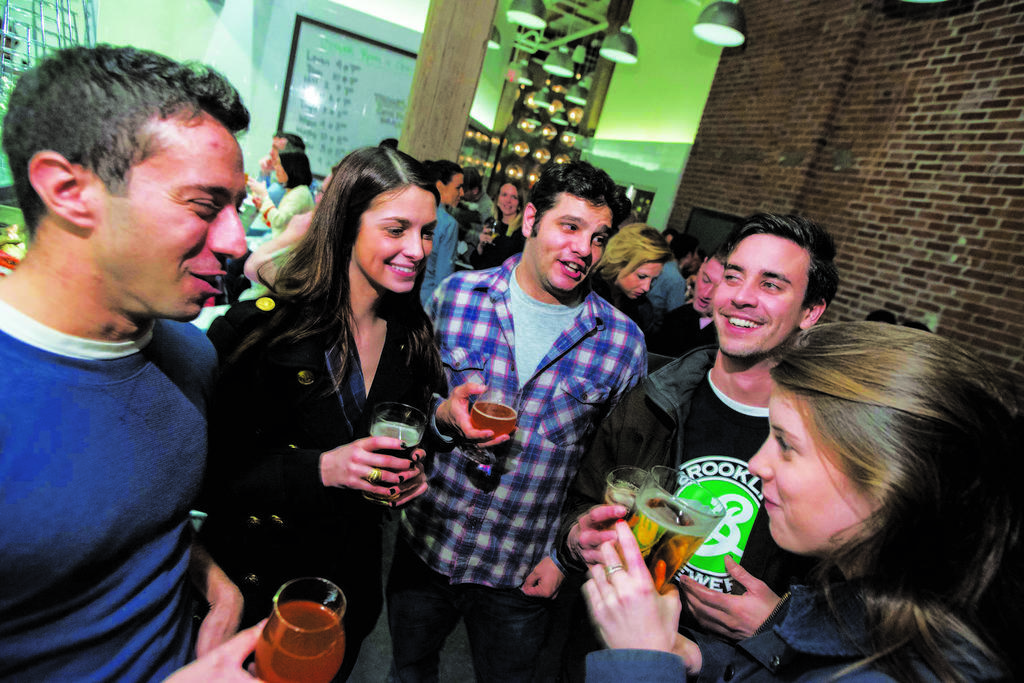Describe this image in one or two sentences. in the image we can see few persons were standing and holding glass and they were smiling. In the background there is a wall,light,board,window and few more persons were standing. 